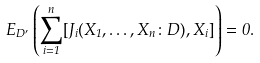<formula> <loc_0><loc_0><loc_500><loc_500>E _ { D ^ { \prime } } \left ( \sum _ { i = 1 } ^ { n } [ J _ { i } ( X _ { 1 } , \dots , X _ { n } \colon D ) , X _ { i } ] \right ) = 0 .</formula> 